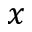Convert formula to latex. <formula><loc_0><loc_0><loc_500><loc_500>x</formula> 